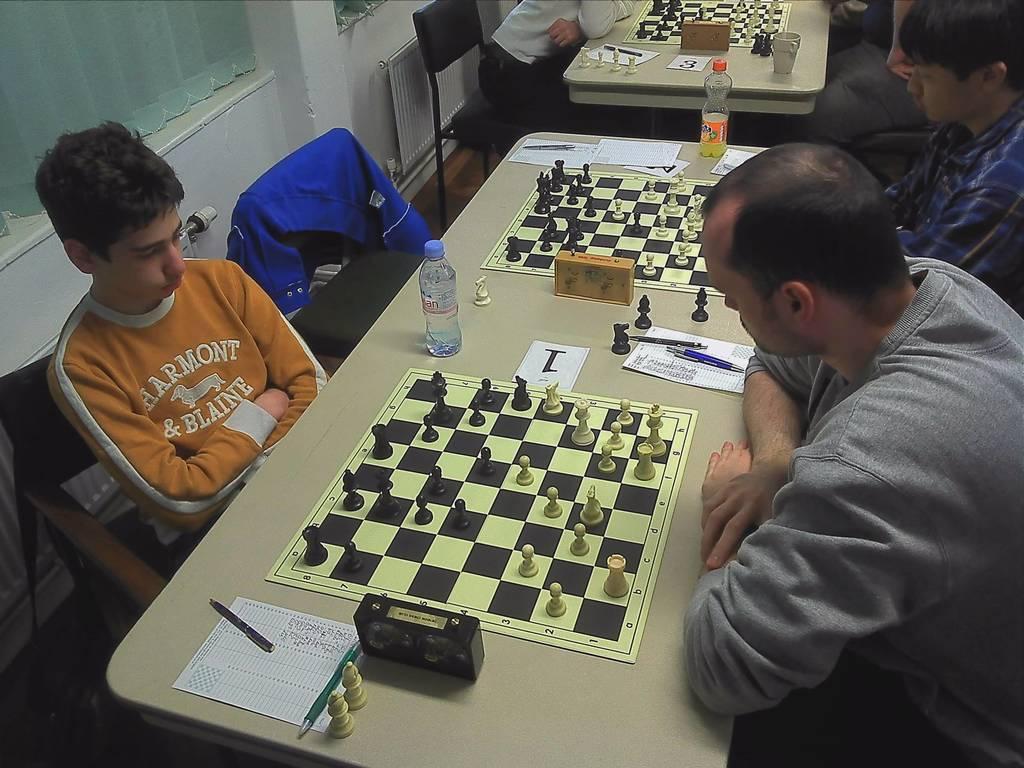How would you summarize this image in a sentence or two? In the middle of the image there is a table, On the table there is a chess board and water bottle, paper and pens. Surrounding the table few people are sitting on the chairs. Top left side of the image there is a wall. 